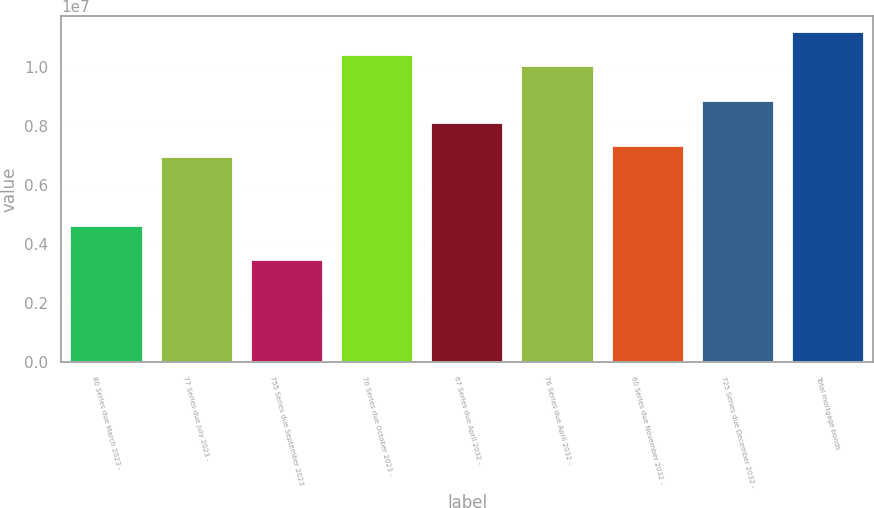Convert chart. <chart><loc_0><loc_0><loc_500><loc_500><bar_chart><fcel>80 Series due March 2023 -<fcel>77 Series due July 2023 -<fcel>755 Series due September 2023<fcel>70 Series due October 2023 -<fcel>67 Series due April 2032 -<fcel>76 Series due April 2032 -<fcel>60 Series due November 2032 -<fcel>725 Series due December 2032 -<fcel>Total mortgage bonds<nl><fcel>4.63041e+06<fcel>6.94165e+06<fcel>3.47479e+06<fcel>1.04085e+07<fcel>8.09727e+06<fcel>1.00233e+07<fcel>7.32686e+06<fcel>8.86768e+06<fcel>1.11789e+07<nl></chart> 